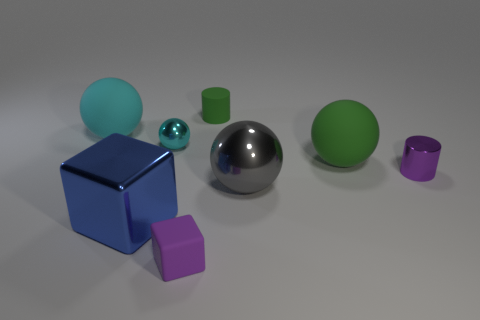What number of things are tiny purple cylinders or balls that are on the left side of the large blue cube?
Offer a very short reply. 2. Is there a small gray matte thing that has the same shape as the small cyan thing?
Offer a terse response. No. What size is the thing left of the cube to the left of the purple rubber cube?
Your response must be concise. Large. Does the small metal cylinder have the same color as the small block?
Offer a terse response. Yes. How many metal objects are gray things or large spheres?
Make the answer very short. 1. How many shiny blocks are there?
Make the answer very short. 1. Is the cyan object to the left of the metal cube made of the same material as the small purple object on the right side of the big gray thing?
Offer a terse response. No. What is the color of the big thing that is the same shape as the tiny purple matte thing?
Provide a short and direct response. Blue. There is a big thing to the right of the metallic ball in front of the purple metallic object; what is its material?
Make the answer very short. Rubber. Is the shape of the large blue shiny thing on the left side of the small metallic cylinder the same as the green rubber thing in front of the big cyan matte sphere?
Your response must be concise. No. 